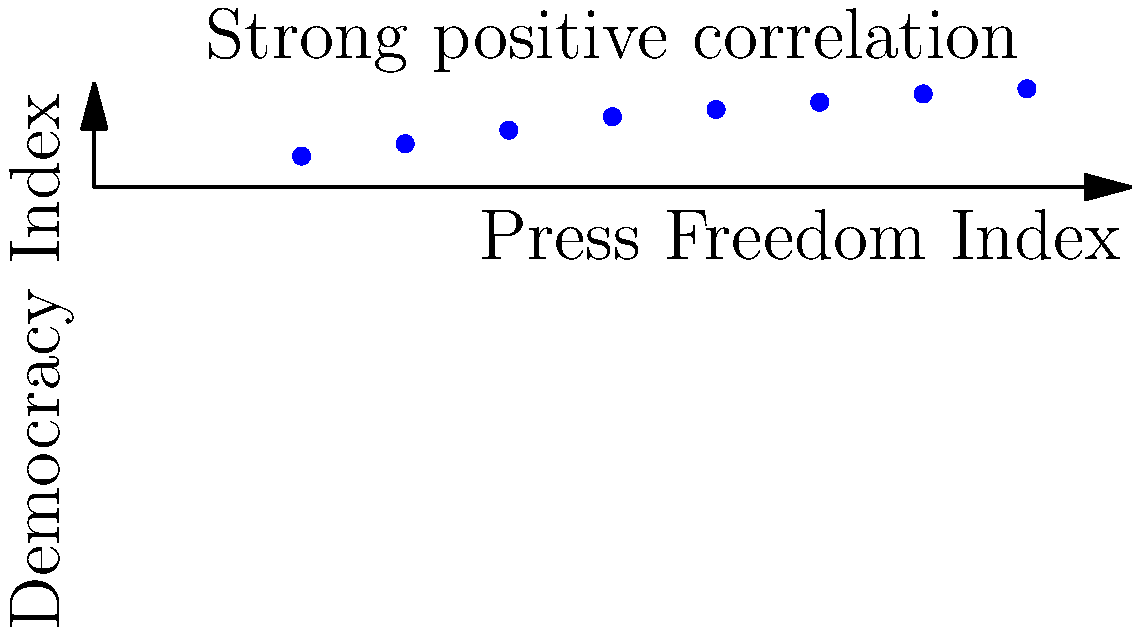Based on the scatter plot showing the relationship between the Press Freedom Index and Democracy Index, what conclusion can be drawn about the correlation between press freedom and democratic strength? How might this information inform policy decisions regarding media consolidation and press freedom in our country? To answer this question, we need to analyze the scatter plot and understand its implications:

1. Observe the overall trend: The data points show a clear upward trend from left to right.

2. Interpret the axes:
   - X-axis represents the Press Freedom Index (0-100)
   - Y-axis represents the Democracy Index (0-10)

3. Analyze the correlation:
   - As the Press Freedom Index increases, the Democracy Index also increases.
   - This indicates a strong positive correlation between press freedom and democratic strength.

4. Understand the implications:
   - Countries with higher press freedom tend to have stronger democracies.
   - This suggests that press freedom is a crucial factor in maintaining and strengthening democratic institutions.

5. Policy considerations:
   - Given the strong correlation, policies that protect and enhance press freedom are likely to support democratic values.
   - Addressing media consolidation issues becomes crucial, as it can impact press freedom and, by extension, democratic strength.
   - Promoting diverse media ownership and preventing excessive concentration of media power may be beneficial for both press freedom and democracy.

6. Relevance to the revival of print news:
   - The revival of print news presents an opportunity to reinforce press freedom.
   - Policies supporting diverse print media outlets could contribute to a higher Press Freedom Index and potentially strengthen democratic institutions.

In conclusion, the scatter plot demonstrates a strong positive correlation between press freedom and democratic strength, suggesting that policies promoting press freedom and addressing media consolidation could have significant positive impacts on the overall health of a democracy.
Answer: Strong positive correlation; policies promoting press freedom and diverse media ownership likely strengthen democracy. 